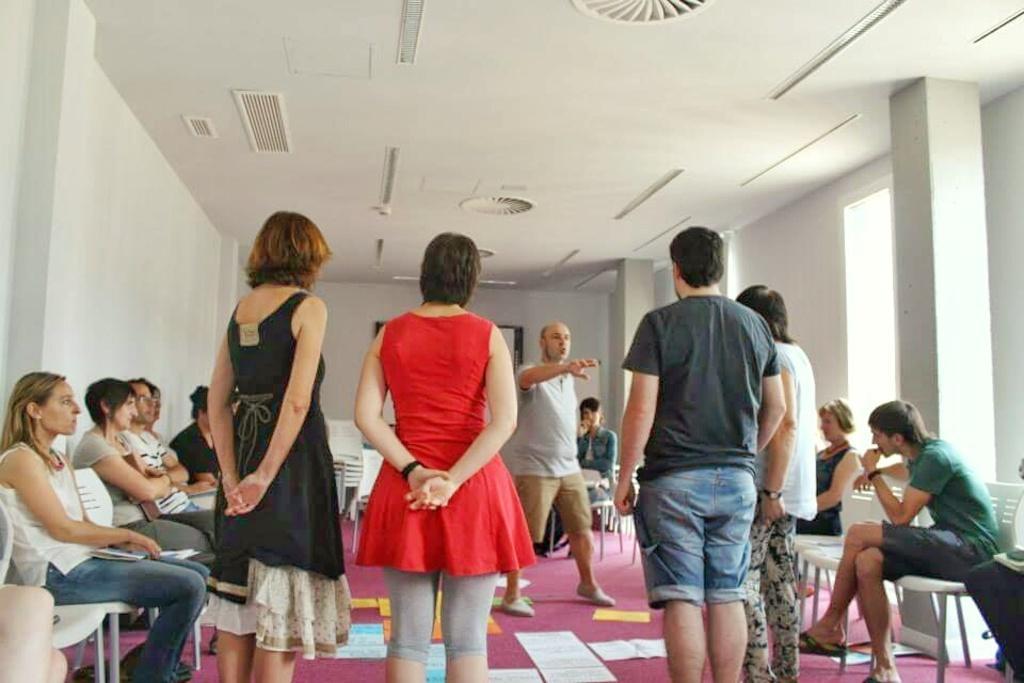Can you describe this image briefly? In this picture I can observe some people sitting in the chairs and some of them are standing. There are men and women in this picture. There are some papers on the floor. In the background there is a wall. 